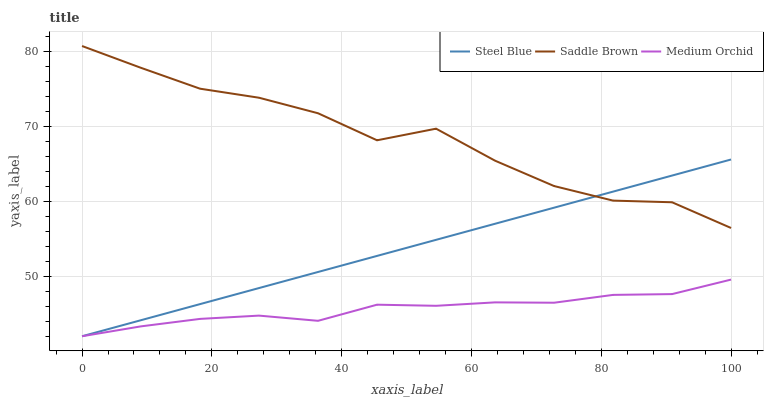Does Medium Orchid have the minimum area under the curve?
Answer yes or no. Yes. Does Saddle Brown have the maximum area under the curve?
Answer yes or no. Yes. Does Steel Blue have the minimum area under the curve?
Answer yes or no. No. Does Steel Blue have the maximum area under the curve?
Answer yes or no. No. Is Steel Blue the smoothest?
Answer yes or no. Yes. Is Saddle Brown the roughest?
Answer yes or no. Yes. Is Saddle Brown the smoothest?
Answer yes or no. No. Is Steel Blue the roughest?
Answer yes or no. No. Does Saddle Brown have the lowest value?
Answer yes or no. No. Does Saddle Brown have the highest value?
Answer yes or no. Yes. Does Steel Blue have the highest value?
Answer yes or no. No. Is Medium Orchid less than Saddle Brown?
Answer yes or no. Yes. Is Saddle Brown greater than Medium Orchid?
Answer yes or no. Yes. Does Steel Blue intersect Saddle Brown?
Answer yes or no. Yes. Is Steel Blue less than Saddle Brown?
Answer yes or no. No. Is Steel Blue greater than Saddle Brown?
Answer yes or no. No. Does Medium Orchid intersect Saddle Brown?
Answer yes or no. No. 